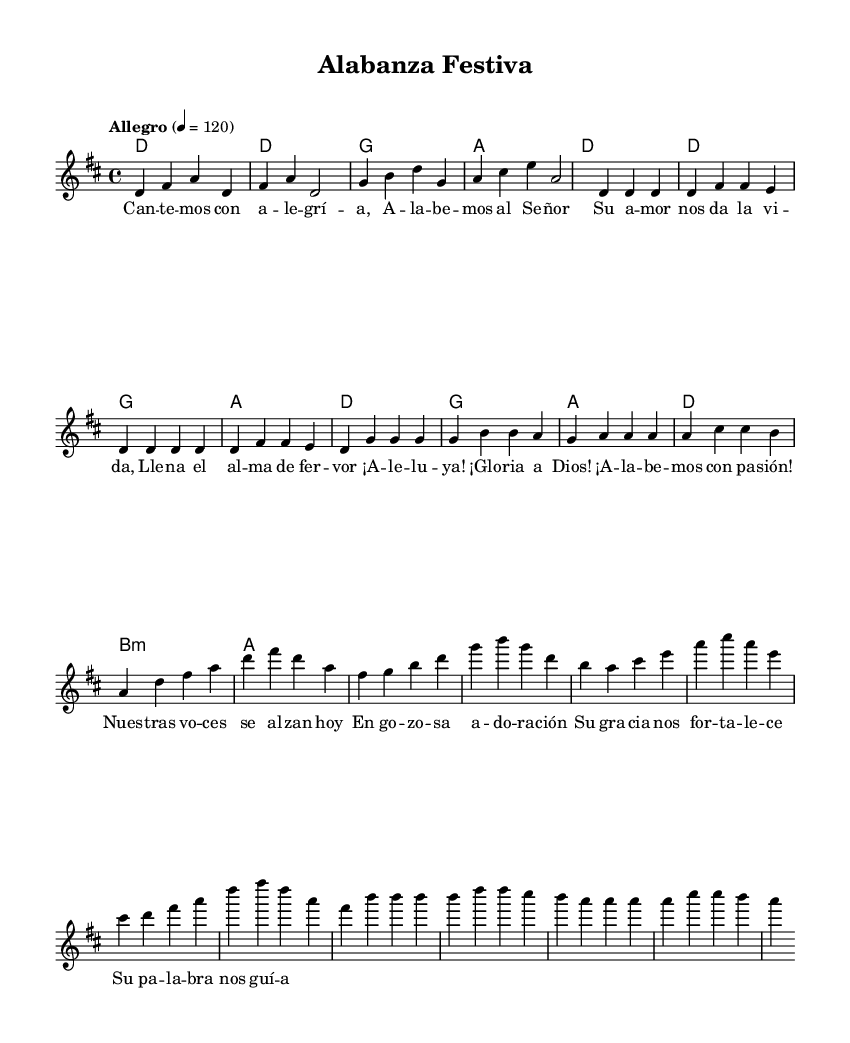What is the key signature of this music? The key signature is indicated by the presence of two sharps (F# and C#), which is characteristic of D major.
Answer: D major What is the time signature of the piece? The time signature is indicated at the beginning of the score. It shows four beats per measure, represented as 4 over 4.
Answer: 4/4 What is the tempo marking for this piece? The tempo marking, shown as "Allegro," indicates a fast and lively pace for the music, along with a specific metronome marking of 120 beats per minute.
Answer: Allegro How many sections are there in the song? By observing the structure outlined in the lyrics and sections such as the intro, verse, chorus, and bridge, there are four distinct sections.
Answer: Four What is the main emotion conveyed by the lyrics in the chorus? The chorus includes phrases like "¡Aleluya! ¡Gloria a Dios!" which express joy and celebration, indicating a very positive and uplifting emotion.
Answer: Joy Which instrument parts are included in this arrangement? The score consists of a chord name part for harmony and a separate staff for the melody voice, clearly indicating its structure with defined lines.
Answer: Melody and harmony 